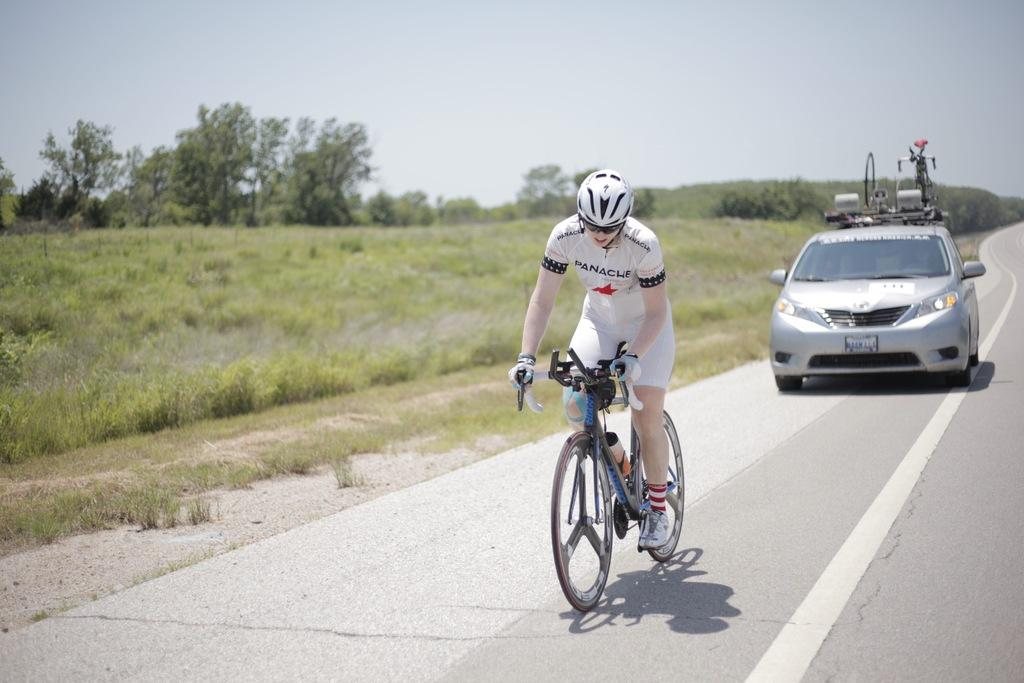What is the person in the image doing? The person is riding a bicycle. What safety precaution is the person taking while riding the bicycle? The person is wearing a helmet. What type of natural environment is visible in the background? There are trees and grass in the background. Are there any vehicles visible in the background? Yes, there is a car in the background. What role does the actor play in the image? There is no actor present in the image, as it features a person riding a bicycle. What type of sack is being used to carry the person's belongings in the image? There is no sack visible in the image; the person is riding a bicycle without any visible bags or sacks. 